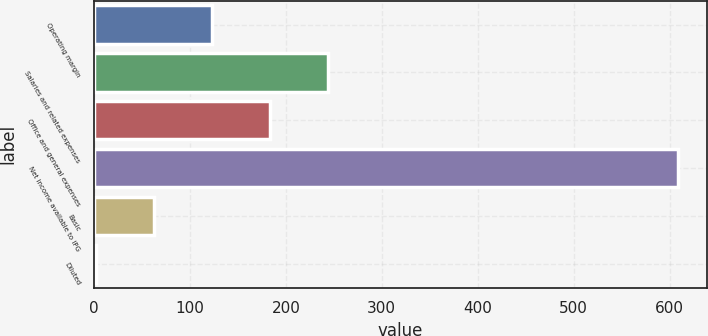<chart> <loc_0><loc_0><loc_500><loc_500><bar_chart><fcel>Operating margin<fcel>Salaries and related expenses<fcel>Office and general expenses<fcel>Net income available to IPG<fcel>Basic<fcel>Diluted<nl><fcel>122.89<fcel>244.29<fcel>183.59<fcel>608.5<fcel>62.19<fcel>1.49<nl></chart> 